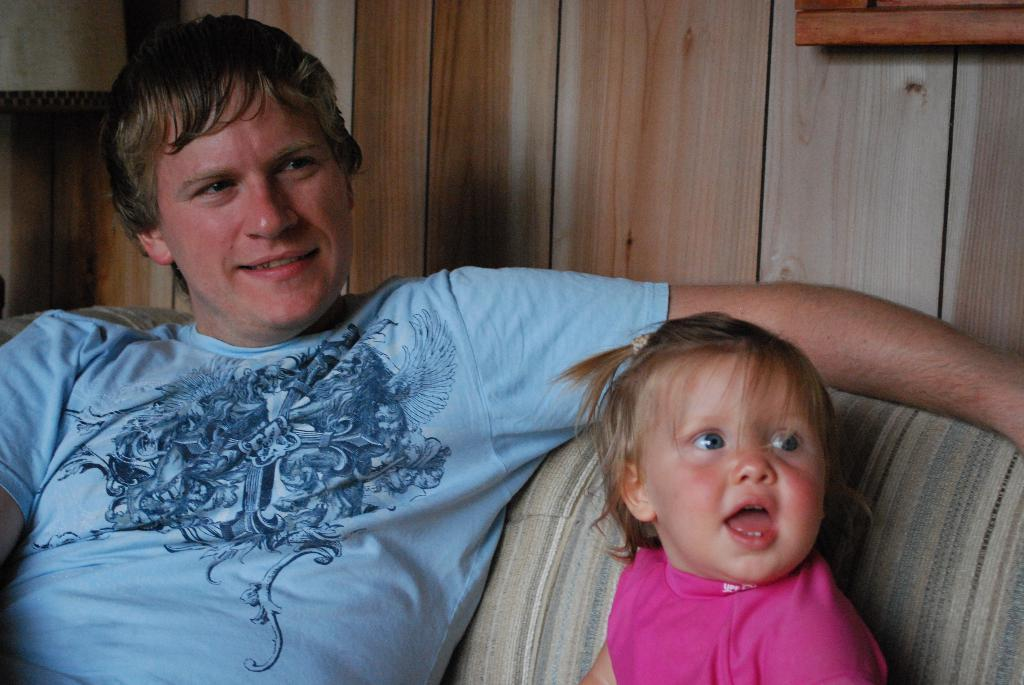How many people are in the image? There are two people in the image. What colors are the dresses of the people in the image? One person is wearing a blue dress, and the other person is wearing a pink dress. Where are the people sitting in the image? The people are sitting on a couch. What type of material can be seen in the background of the image? There is a wooden wall in the background of the image. What type of crow is sitting on the window in the image? There is no crow or window present in the image. What is the neck size of the person wearing the blue dress in the image? The image does not provide information about the neck size of the person wearing the blue dress. 